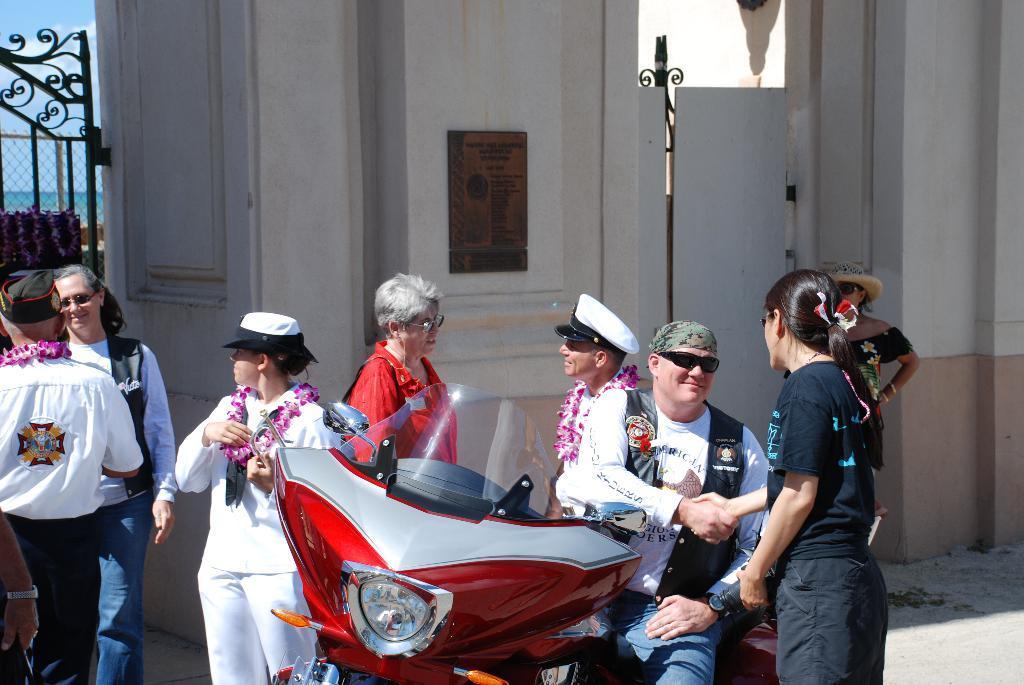Please provide a concise description of this image. In the picture there is a red color bike and a man is sitting on the bike is giving shake hand to the person behind him, there are also other group of people are wearing a pink color garland ,in the background there is a gate and white color wall. 